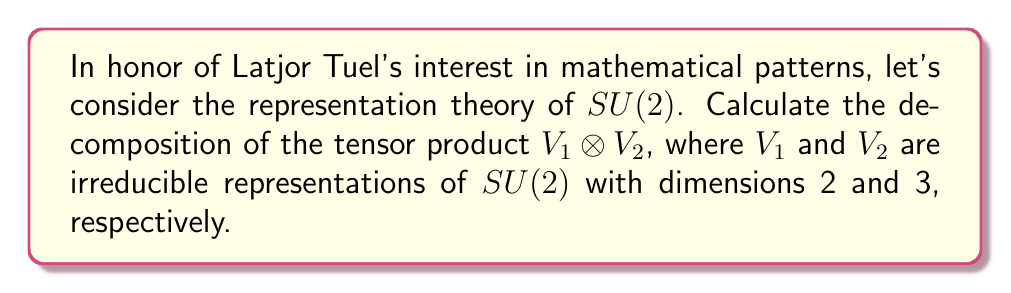Can you answer this question? Let's approach this step-by-step:

1) In $SU(2)$ representation theory, irreducible representations are labeled by half-integers $j$, where the dimension of the representation is $2j+1$.

2) Given the dimensions, we can identify:
   $V_1$ as the $j=\frac{1}{2}$ representation (dim = 2)
   $V_2$ as the $j=1$ representation (dim = 3)

3) The Clebsch-Gordan series for $SU(2)$ states that:

   $$V_j \otimes V_k = V_{|j-k|} \oplus V_{|j-k|+1} \oplus ... \oplus V_{j+k-1} \oplus V_{j+k}$$

4) In our case, $j=\frac{1}{2}$ and $k=1$, so:

   $$V_{\frac{1}{2}} \otimes V_1 = V_{|\frac{1}{2}-1|} \oplus V_{|\frac{1}{2}-1|+1} \oplus V_{\frac{1}{2}+1}$$

5) Simplifying:

   $$V_{\frac{1}{2}} \otimes V_1 = V_{\frac{1}{2}} \oplus V_{\frac{3}{2}}$$

6) To verify dimensions: 
   Left side: $2 \times 3 = 6$
   Right side: $(2\cdot\frac{1}{2}+1) + (2\cdot\frac{3}{2}+1) = 2 + 4 = 6$

Therefore, the tensor product decomposes into the direct sum of the $j=\frac{1}{2}$ and $j=\frac{3}{2}$ representations.
Answer: $V_{\frac{1}{2}} \otimes V_1 = V_{\frac{1}{2}} \oplus V_{\frac{3}{2}}$ 